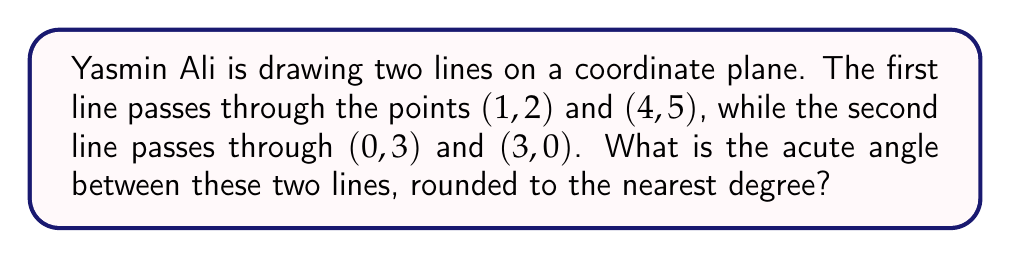Teach me how to tackle this problem. Let's approach this step-by-step:

1) First, we need to find the slopes of both lines.

   For line 1: $m_1 = \frac{5-2}{4-1} = 1$

   For line 2: $m_2 = \frac{0-3}{3-0} = -1$

2) The formula for the angle $\theta$ between two lines with slopes $m_1$ and $m_2$ is:

   $$\tan \theta = \left|\frac{m_2 - m_1}{1 + m_1m_2}\right|$$

3) Let's substitute our values:

   $$\tan \theta = \left|\frac{-1 - 1}{1 + 1(-1)}\right| = \left|\frac{-2}{0}\right|$$

4) This results in an undefined value, which means the angle is 90°. This makes sense because the slopes are negative reciprocals of each other, indicating perpendicular lines.

5) However, the question asks for the acute angle. In this case, the acute angle is the same as the right angle: 90°.

[asy]
import geometry;

size(200);
defaultpen(fontsize(10pt));

pair A = (1,2), B = (4,5), C = (0,3), D = (3,0);
draw(A--B, blue);
draw(C--D, red);

label("(1,2)", A, SW);
label("(4,5)", B, NE);
label("(0,3)", C, NW);
label("(3,0)", D, SE);

dot(A); dot(B); dot(C); dot(D);

pair E = extension(A--B, C--D);
draw(rightangle(A,E,D,20));

label("90°", E, NE);
[/asy]
Answer: 90° 